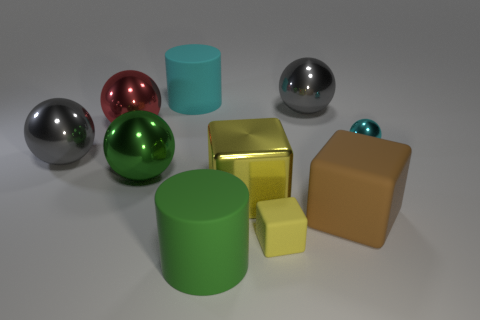Can you describe the differences between the objects in the image? Certainly! There are several objects of different shapes, sizes, and colors. We have spheres, a cube, a cylinder, and some are shiny indicating a reflective material, while others have a matte finish suggesting a more diffuse material. 